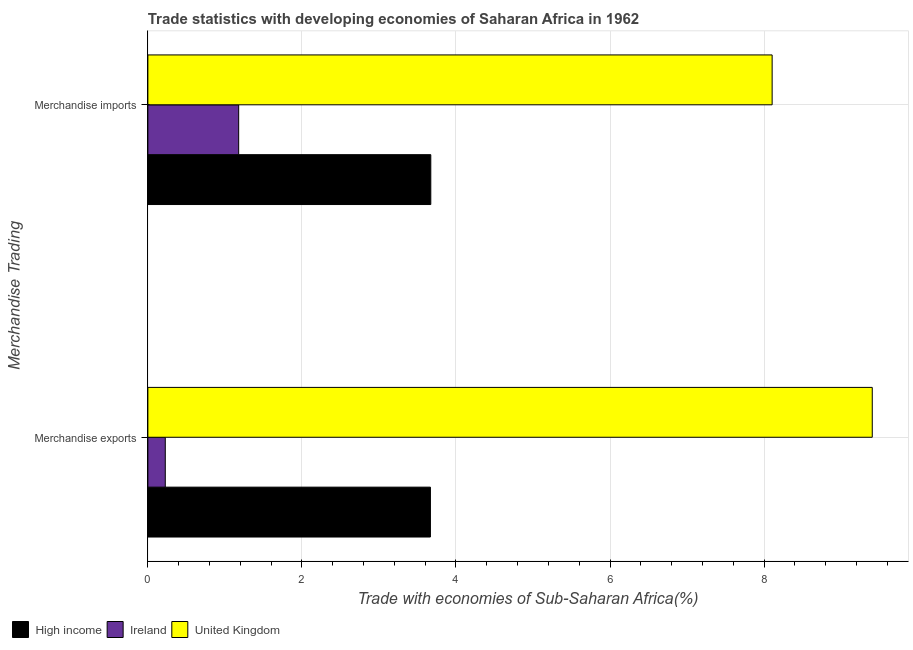How many different coloured bars are there?
Make the answer very short. 3. Are the number of bars per tick equal to the number of legend labels?
Offer a terse response. Yes. What is the merchandise exports in Ireland?
Your answer should be very brief. 0.23. Across all countries, what is the maximum merchandise exports?
Make the answer very short. 9.4. Across all countries, what is the minimum merchandise imports?
Provide a succinct answer. 1.18. In which country was the merchandise imports maximum?
Provide a short and direct response. United Kingdom. In which country was the merchandise imports minimum?
Provide a succinct answer. Ireland. What is the total merchandise exports in the graph?
Your response must be concise. 13.3. What is the difference between the merchandise exports in United Kingdom and that in High income?
Provide a succinct answer. 5.74. What is the difference between the merchandise imports in United Kingdom and the merchandise exports in High income?
Your answer should be very brief. 4.44. What is the average merchandise imports per country?
Offer a very short reply. 4.32. What is the difference between the merchandise imports and merchandise exports in United Kingdom?
Provide a succinct answer. -1.3. In how many countries, is the merchandise exports greater than 9.2 %?
Offer a very short reply. 1. What is the ratio of the merchandise imports in High income to that in United Kingdom?
Ensure brevity in your answer.  0.45. Is the merchandise exports in United Kingdom less than that in Ireland?
Keep it short and to the point. No. What does the 2nd bar from the top in Merchandise imports represents?
Make the answer very short. Ireland. What does the 2nd bar from the bottom in Merchandise exports represents?
Your answer should be compact. Ireland. How many countries are there in the graph?
Provide a short and direct response. 3. What is the difference between two consecutive major ticks on the X-axis?
Ensure brevity in your answer.  2. What is the title of the graph?
Offer a terse response. Trade statistics with developing economies of Saharan Africa in 1962. Does "Central Europe" appear as one of the legend labels in the graph?
Your answer should be compact. No. What is the label or title of the X-axis?
Your response must be concise. Trade with economies of Sub-Saharan Africa(%). What is the label or title of the Y-axis?
Give a very brief answer. Merchandise Trading. What is the Trade with economies of Sub-Saharan Africa(%) in High income in Merchandise exports?
Your answer should be compact. 3.67. What is the Trade with economies of Sub-Saharan Africa(%) in Ireland in Merchandise exports?
Your answer should be compact. 0.23. What is the Trade with economies of Sub-Saharan Africa(%) in United Kingdom in Merchandise exports?
Your answer should be compact. 9.4. What is the Trade with economies of Sub-Saharan Africa(%) in High income in Merchandise imports?
Offer a very short reply. 3.67. What is the Trade with economies of Sub-Saharan Africa(%) in Ireland in Merchandise imports?
Provide a succinct answer. 1.18. What is the Trade with economies of Sub-Saharan Africa(%) of United Kingdom in Merchandise imports?
Give a very brief answer. 8.1. Across all Merchandise Trading, what is the maximum Trade with economies of Sub-Saharan Africa(%) of High income?
Make the answer very short. 3.67. Across all Merchandise Trading, what is the maximum Trade with economies of Sub-Saharan Africa(%) of Ireland?
Keep it short and to the point. 1.18. Across all Merchandise Trading, what is the maximum Trade with economies of Sub-Saharan Africa(%) of United Kingdom?
Offer a terse response. 9.4. Across all Merchandise Trading, what is the minimum Trade with economies of Sub-Saharan Africa(%) of High income?
Ensure brevity in your answer.  3.67. Across all Merchandise Trading, what is the minimum Trade with economies of Sub-Saharan Africa(%) in Ireland?
Offer a very short reply. 0.23. Across all Merchandise Trading, what is the minimum Trade with economies of Sub-Saharan Africa(%) of United Kingdom?
Ensure brevity in your answer.  8.1. What is the total Trade with economies of Sub-Saharan Africa(%) of High income in the graph?
Give a very brief answer. 7.34. What is the total Trade with economies of Sub-Saharan Africa(%) of Ireland in the graph?
Keep it short and to the point. 1.4. What is the total Trade with economies of Sub-Saharan Africa(%) of United Kingdom in the graph?
Keep it short and to the point. 17.51. What is the difference between the Trade with economies of Sub-Saharan Africa(%) in High income in Merchandise exports and that in Merchandise imports?
Make the answer very short. -0.01. What is the difference between the Trade with economies of Sub-Saharan Africa(%) of Ireland in Merchandise exports and that in Merchandise imports?
Your answer should be very brief. -0.95. What is the difference between the Trade with economies of Sub-Saharan Africa(%) of United Kingdom in Merchandise exports and that in Merchandise imports?
Keep it short and to the point. 1.3. What is the difference between the Trade with economies of Sub-Saharan Africa(%) in High income in Merchandise exports and the Trade with economies of Sub-Saharan Africa(%) in Ireland in Merchandise imports?
Make the answer very short. 2.49. What is the difference between the Trade with economies of Sub-Saharan Africa(%) of High income in Merchandise exports and the Trade with economies of Sub-Saharan Africa(%) of United Kingdom in Merchandise imports?
Your response must be concise. -4.44. What is the difference between the Trade with economies of Sub-Saharan Africa(%) of Ireland in Merchandise exports and the Trade with economies of Sub-Saharan Africa(%) of United Kingdom in Merchandise imports?
Provide a succinct answer. -7.88. What is the average Trade with economies of Sub-Saharan Africa(%) in High income per Merchandise Trading?
Provide a succinct answer. 3.67. What is the average Trade with economies of Sub-Saharan Africa(%) in Ireland per Merchandise Trading?
Give a very brief answer. 0.7. What is the average Trade with economies of Sub-Saharan Africa(%) of United Kingdom per Merchandise Trading?
Provide a succinct answer. 8.75. What is the difference between the Trade with economies of Sub-Saharan Africa(%) of High income and Trade with economies of Sub-Saharan Africa(%) of Ireland in Merchandise exports?
Keep it short and to the point. 3.44. What is the difference between the Trade with economies of Sub-Saharan Africa(%) in High income and Trade with economies of Sub-Saharan Africa(%) in United Kingdom in Merchandise exports?
Make the answer very short. -5.74. What is the difference between the Trade with economies of Sub-Saharan Africa(%) in Ireland and Trade with economies of Sub-Saharan Africa(%) in United Kingdom in Merchandise exports?
Provide a short and direct response. -9.18. What is the difference between the Trade with economies of Sub-Saharan Africa(%) in High income and Trade with economies of Sub-Saharan Africa(%) in Ireland in Merchandise imports?
Your answer should be very brief. 2.49. What is the difference between the Trade with economies of Sub-Saharan Africa(%) of High income and Trade with economies of Sub-Saharan Africa(%) of United Kingdom in Merchandise imports?
Offer a very short reply. -4.43. What is the difference between the Trade with economies of Sub-Saharan Africa(%) in Ireland and Trade with economies of Sub-Saharan Africa(%) in United Kingdom in Merchandise imports?
Your answer should be very brief. -6.93. What is the ratio of the Trade with economies of Sub-Saharan Africa(%) in High income in Merchandise exports to that in Merchandise imports?
Your response must be concise. 1. What is the ratio of the Trade with economies of Sub-Saharan Africa(%) of Ireland in Merchandise exports to that in Merchandise imports?
Provide a succinct answer. 0.19. What is the ratio of the Trade with economies of Sub-Saharan Africa(%) in United Kingdom in Merchandise exports to that in Merchandise imports?
Give a very brief answer. 1.16. What is the difference between the highest and the second highest Trade with economies of Sub-Saharan Africa(%) of High income?
Your answer should be very brief. 0.01. What is the difference between the highest and the second highest Trade with economies of Sub-Saharan Africa(%) in Ireland?
Your answer should be compact. 0.95. What is the difference between the highest and the second highest Trade with economies of Sub-Saharan Africa(%) of United Kingdom?
Provide a short and direct response. 1.3. What is the difference between the highest and the lowest Trade with economies of Sub-Saharan Africa(%) in High income?
Ensure brevity in your answer.  0.01. What is the difference between the highest and the lowest Trade with economies of Sub-Saharan Africa(%) of Ireland?
Give a very brief answer. 0.95. What is the difference between the highest and the lowest Trade with economies of Sub-Saharan Africa(%) in United Kingdom?
Your answer should be compact. 1.3. 